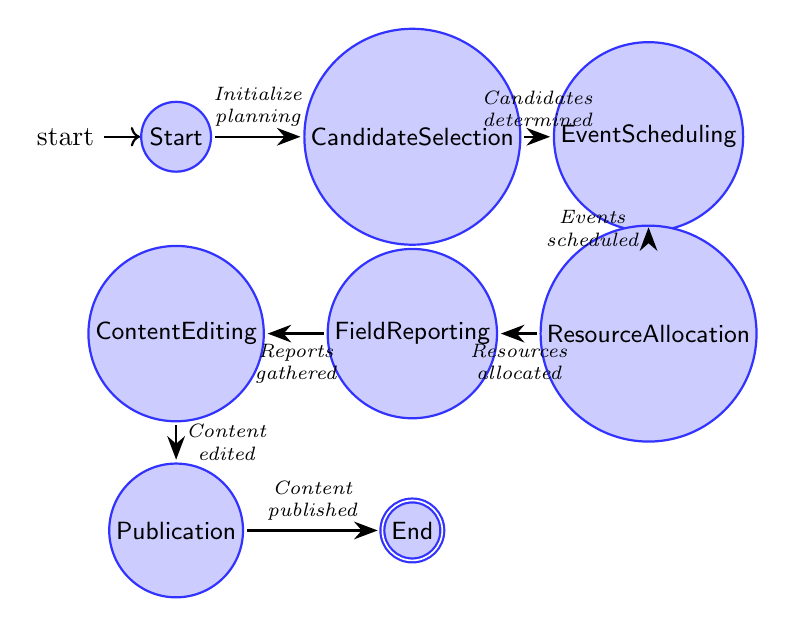What is the first state in the diagram? The first state is labeled "Start," which indicates the beginning of the campaign trail coverage planning process.
Answer: Start How many states are depicted in the diagram? By counting the number of different states listed in the diagram, we see that there are a total of eight states.
Answer: Eight What action transitions from "Candidate Selection" to "Event Scheduling"? The transition is labeled "Candidates determined," indicating that once candidates are selected, the next step is to schedule events.
Answer: Candidates determined Which state comes before "Field Reporting"? The node that comes directly before "Field Reporting" is "Resource Allocation," which indicates that resources need to be properly allocated for reporting.
Answer: Resource Allocation What is the final state of the coverage plan? The final state is indicated with the label "End," signifying the completion of the campaign trail coverage process.
Answer: End What action follows "Content Editing"? The action that follows "Content Editing" is labeled "Content published," indicating the step where finalized content is shared through media outlets.
Answer: Content published How many transitions are illustrated in the diagram? By counting the arrows connecting the states in the diagram, we see that there are seven transitions connecting each stage of the process.
Answer: Seven What state is directly connected to "Publication"? "Publication" is directly connected to the state labeled "End," which indicates that publication is the last step before the process concludes.
Answer: End What actions are needed to move from "Resource Allocation" to "Field Reporting"? The action required to transition from "Resource Allocation" to "Field Reporting" is labeled "Resources allocated," meaning resources must be successfully allocated before reporting can occur.
Answer: Resources allocated What must happen before "Content Editing"? Before "Content Editing" occurs, the state "Field Reporting" must be completed, indicating that reports must be gathered from the field prior to editing.
Answer: Field Reporting 